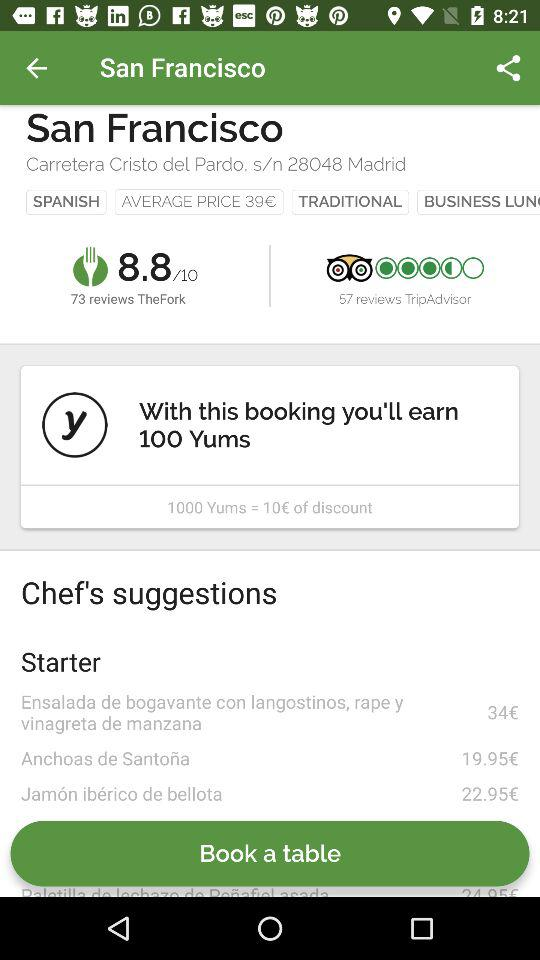What is the average price? The average price is 39€. 